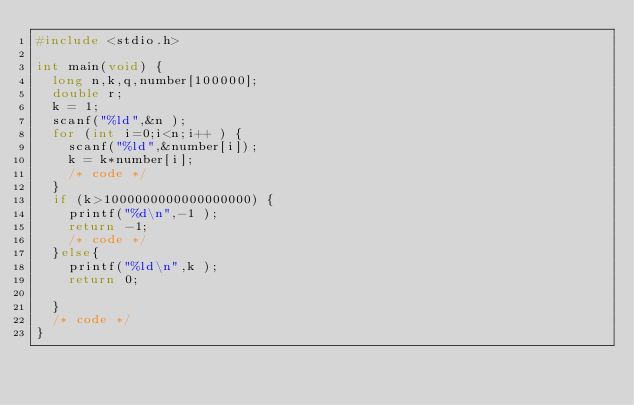Convert code to text. <code><loc_0><loc_0><loc_500><loc_500><_C_>#include <stdio.h>

int main(void) {
  long n,k,q,number[100000];
  double r;
  k = 1;
  scanf("%ld",&n );
  for (int i=0;i<n;i++ ) {
    scanf("%ld",&number[i]);
    k = k*number[i];
    /* code */
  }
  if (k>1000000000000000000) {
    printf("%d\n",-1 );
    return -1;
    /* code */
  }else{
    printf("%ld\n",k );
    return 0;

  }
  /* code */
}</code> 